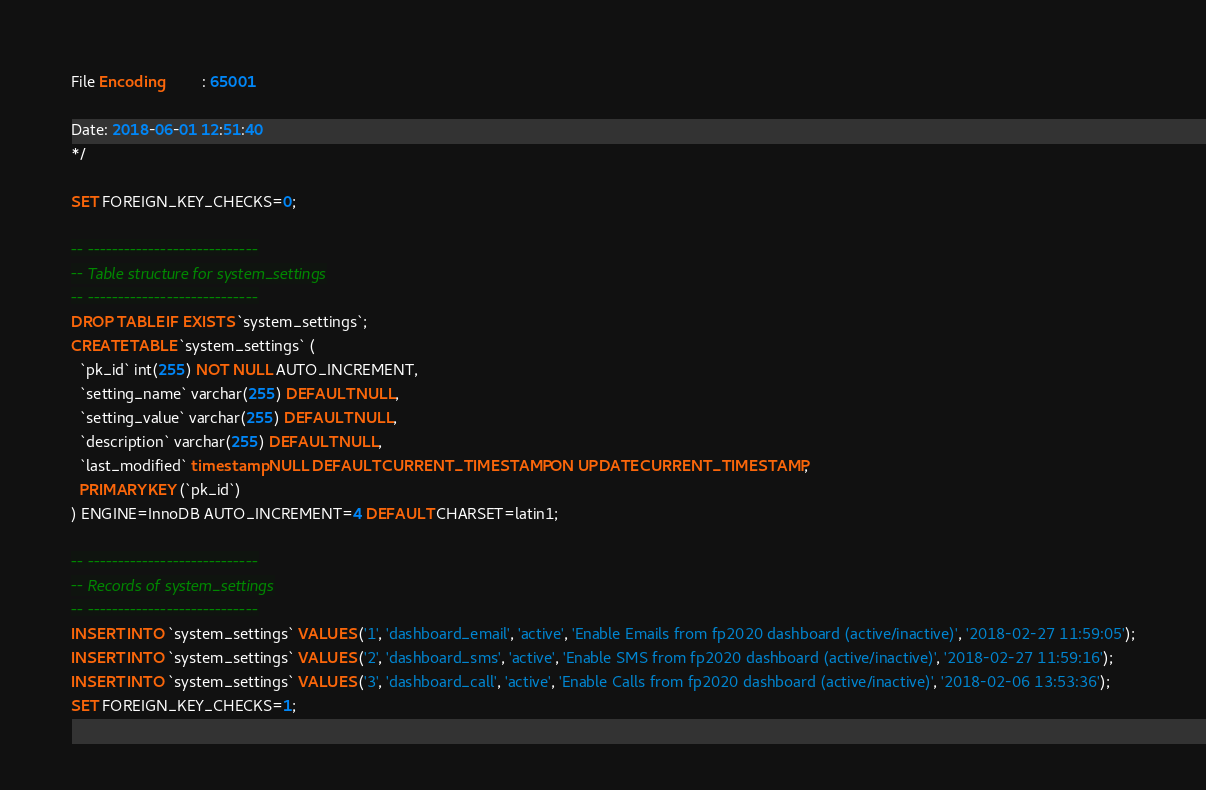Convert code to text. <code><loc_0><loc_0><loc_500><loc_500><_SQL_>File Encoding         : 65001

Date: 2018-06-01 12:51:40
*/

SET FOREIGN_KEY_CHECKS=0;

-- ----------------------------
-- Table structure for system_settings
-- ----------------------------
DROP TABLE IF EXISTS `system_settings`;
CREATE TABLE `system_settings` (
  `pk_id` int(255) NOT NULL AUTO_INCREMENT,
  `setting_name` varchar(255) DEFAULT NULL,
  `setting_value` varchar(255) DEFAULT NULL,
  `description` varchar(255) DEFAULT NULL,
  `last_modified` timestamp NULL DEFAULT CURRENT_TIMESTAMP ON UPDATE CURRENT_TIMESTAMP,
  PRIMARY KEY (`pk_id`)
) ENGINE=InnoDB AUTO_INCREMENT=4 DEFAULT CHARSET=latin1;

-- ----------------------------
-- Records of system_settings
-- ----------------------------
INSERT INTO `system_settings` VALUES ('1', 'dashboard_email', 'active', 'Enable Emails from fp2020 dashboard (active/inactive)', '2018-02-27 11:59:05');
INSERT INTO `system_settings` VALUES ('2', 'dashboard_sms', 'active', 'Enable SMS from fp2020 dashboard (active/inactive)', '2018-02-27 11:59:16');
INSERT INTO `system_settings` VALUES ('3', 'dashboard_call', 'active', 'Enable Calls from fp2020 dashboard (active/inactive)', '2018-02-06 13:53:36');
SET FOREIGN_KEY_CHECKS=1;
</code> 